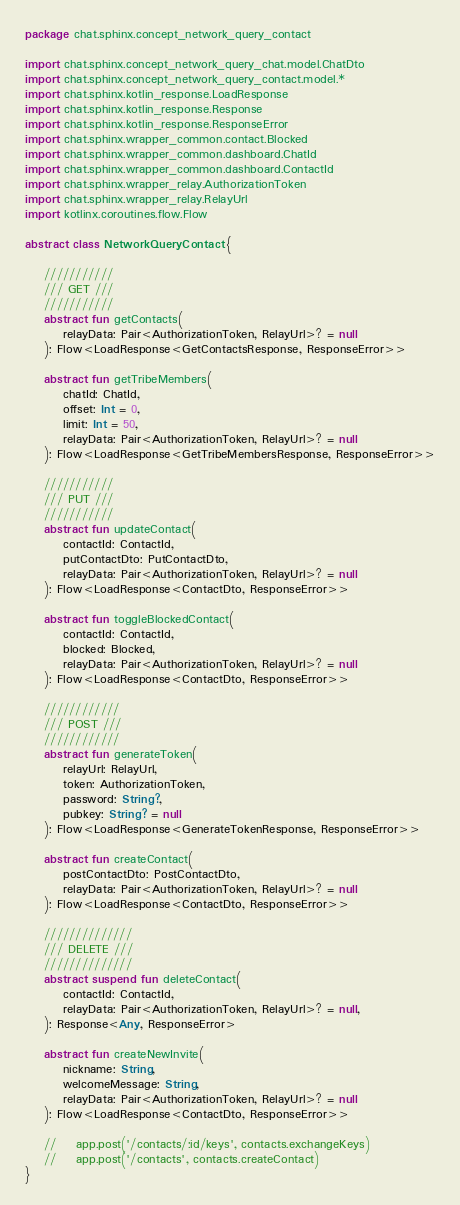<code> <loc_0><loc_0><loc_500><loc_500><_Kotlin_>package chat.sphinx.concept_network_query_contact

import chat.sphinx.concept_network_query_chat.model.ChatDto
import chat.sphinx.concept_network_query_contact.model.*
import chat.sphinx.kotlin_response.LoadResponse
import chat.sphinx.kotlin_response.Response
import chat.sphinx.kotlin_response.ResponseError
import chat.sphinx.wrapper_common.contact.Blocked
import chat.sphinx.wrapper_common.dashboard.ChatId
import chat.sphinx.wrapper_common.dashboard.ContactId
import chat.sphinx.wrapper_relay.AuthorizationToken
import chat.sphinx.wrapper_relay.RelayUrl
import kotlinx.coroutines.flow.Flow

abstract class NetworkQueryContact {

    ///////////
    /// GET ///
    ///////////
    abstract fun getContacts(
        relayData: Pair<AuthorizationToken, RelayUrl>? = null
    ): Flow<LoadResponse<GetContactsResponse, ResponseError>>

    abstract fun getTribeMembers(
        chatId: ChatId,
        offset: Int = 0,
        limit: Int = 50,
        relayData: Pair<AuthorizationToken, RelayUrl>? = null
    ): Flow<LoadResponse<GetTribeMembersResponse, ResponseError>>

    ///////////
    /// PUT ///
    ///////////
    abstract fun updateContact(
        contactId: ContactId,
        putContactDto: PutContactDto,
        relayData: Pair<AuthorizationToken, RelayUrl>? = null
    ): Flow<LoadResponse<ContactDto, ResponseError>>

    abstract fun toggleBlockedContact(
        contactId: ContactId,
        blocked: Blocked,
        relayData: Pair<AuthorizationToken, RelayUrl>? = null
    ): Flow<LoadResponse<ContactDto, ResponseError>>

    ////////////
    /// POST ///
    ////////////
    abstract fun generateToken(
        relayUrl: RelayUrl,
        token: AuthorizationToken,
        password: String?,
        pubkey: String? = null
    ): Flow<LoadResponse<GenerateTokenResponse, ResponseError>>

    abstract fun createContact(
        postContactDto: PostContactDto,
        relayData: Pair<AuthorizationToken, RelayUrl>? = null
    ): Flow<LoadResponse<ContactDto, ResponseError>>

    //////////////
    /// DELETE ///
    //////////////
    abstract suspend fun deleteContact(
        contactId: ContactId,
        relayData: Pair<AuthorizationToken, RelayUrl>? = null,
    ): Response<Any, ResponseError>

    abstract fun createNewInvite(
        nickname: String,
        welcomeMessage: String,
        relayData: Pair<AuthorizationToken, RelayUrl>? = null
    ): Flow<LoadResponse<ContactDto, ResponseError>>

    //    app.post('/contacts/:id/keys', contacts.exchangeKeys)
    //    app.post('/contacts', contacts.createContact)
}
</code> 